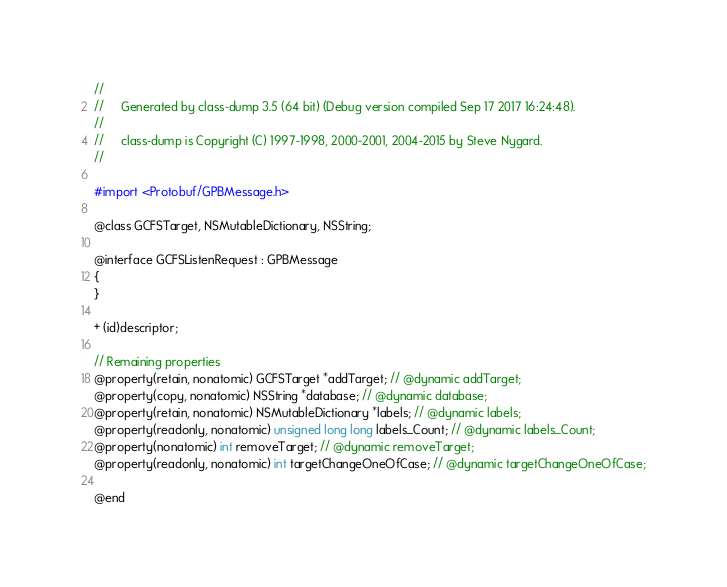<code> <loc_0><loc_0><loc_500><loc_500><_C_>//
//     Generated by class-dump 3.5 (64 bit) (Debug version compiled Sep 17 2017 16:24:48).
//
//     class-dump is Copyright (C) 1997-1998, 2000-2001, 2004-2015 by Steve Nygard.
//

#import <Protobuf/GPBMessage.h>

@class GCFSTarget, NSMutableDictionary, NSString;

@interface GCFSListenRequest : GPBMessage
{
}

+ (id)descriptor;

// Remaining properties
@property(retain, nonatomic) GCFSTarget *addTarget; // @dynamic addTarget;
@property(copy, nonatomic) NSString *database; // @dynamic database;
@property(retain, nonatomic) NSMutableDictionary *labels; // @dynamic labels;
@property(readonly, nonatomic) unsigned long long labels_Count; // @dynamic labels_Count;
@property(nonatomic) int removeTarget; // @dynamic removeTarget;
@property(readonly, nonatomic) int targetChangeOneOfCase; // @dynamic targetChangeOneOfCase;

@end

</code> 